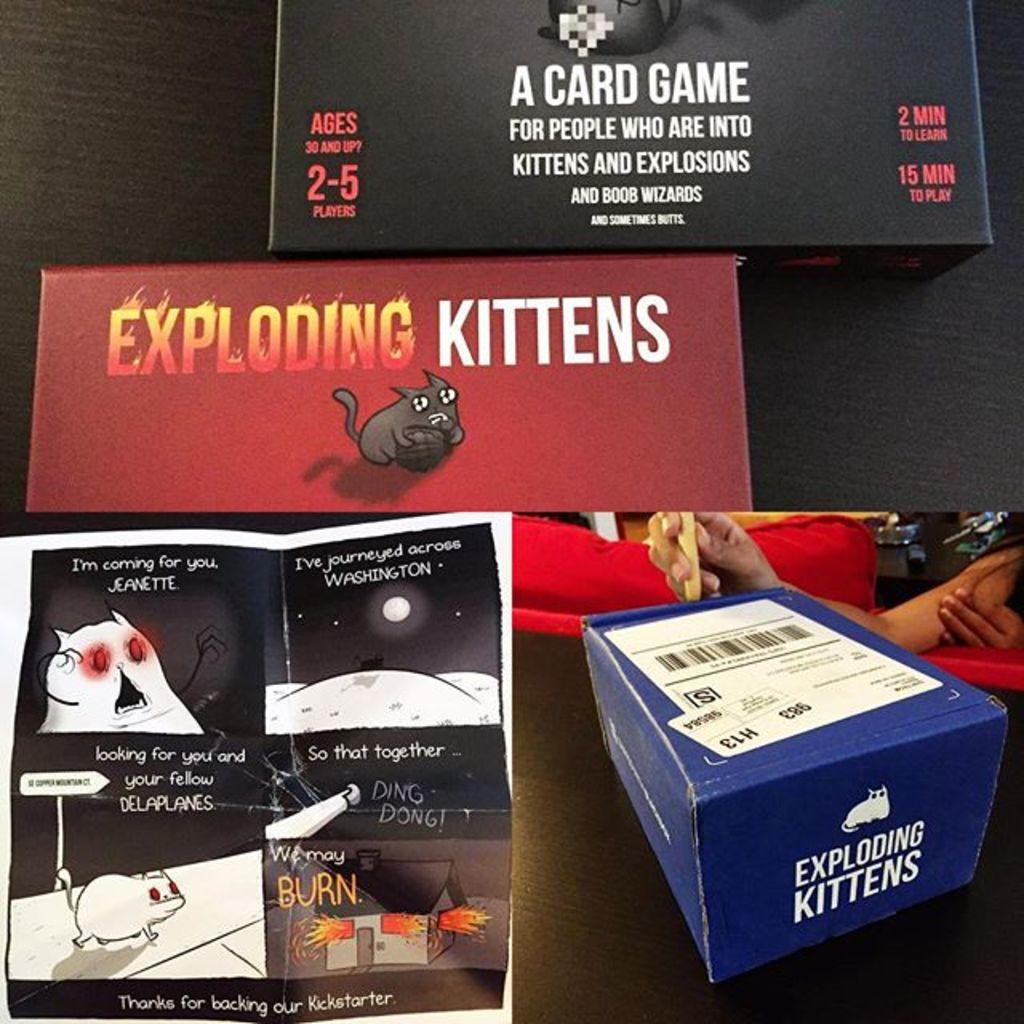What type of game is mentioned in the box on the top?
Your response must be concise. A card game. 